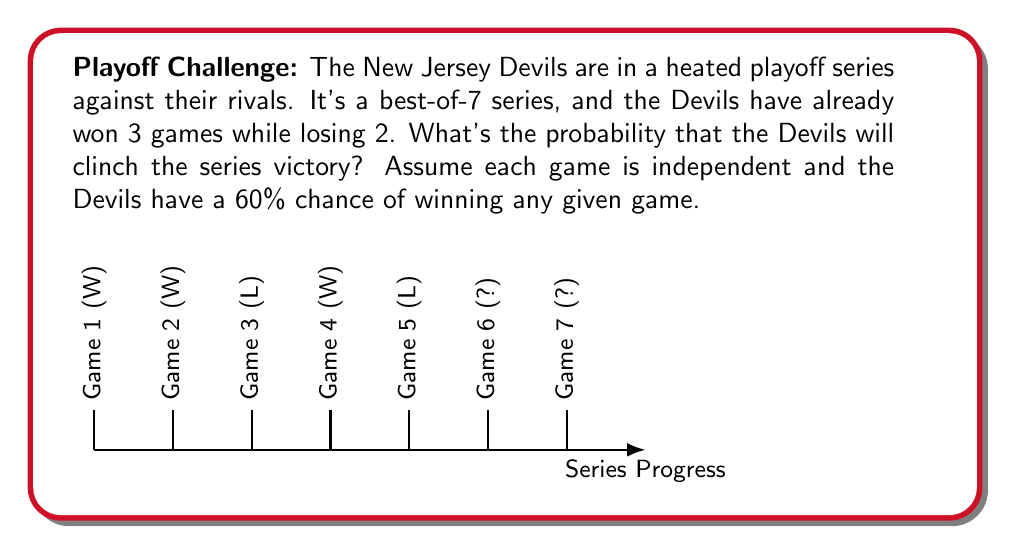Solve this math problem. Let's break this down, you Devils diehards:

1) The Devils need to win just one more game out of the possible two remaining.

2) There are three possible scenarios:
   a) Devils win Game 6 (series ends)
   b) Devils lose Game 6, win Game 7
   c) Devils lose both games (Devils lose series)

3) Probability of winning Game 6:
   $P(\text{Win Game 6}) = 0.6$

4) Probability of losing Game 6 and winning Game 7:
   $P(\text{Lose Game 6 AND Win Game 7}) = 0.4 \times 0.6 = 0.24$

5) Total probability of winning the series:
   $$P(\text{Win Series}) = P(\text{Win Game 6}) + P(\text{Lose Game 6 AND Win Game 7})$$
   $$P(\text{Win Series}) = 0.6 + 0.24 = 0.84$$

6) Convert to percentage:
   $0.84 \times 100\% = 84\%$

Therefore, the Devils have an 84% chance of clinching the series victory. Let's go Devils!
Answer: 84% 